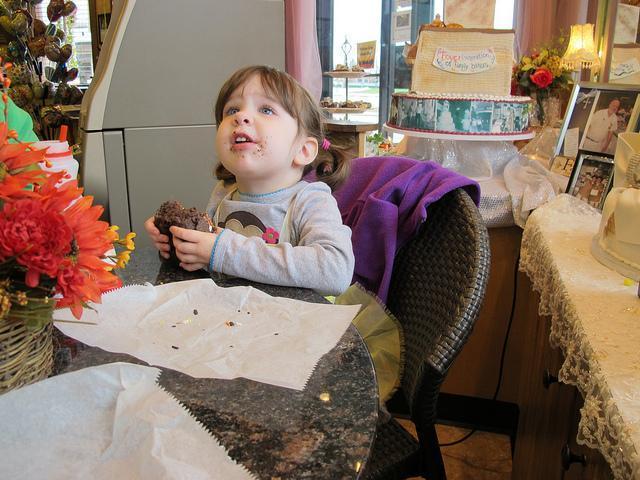How many chairs are in the photo?
Give a very brief answer. 1. 